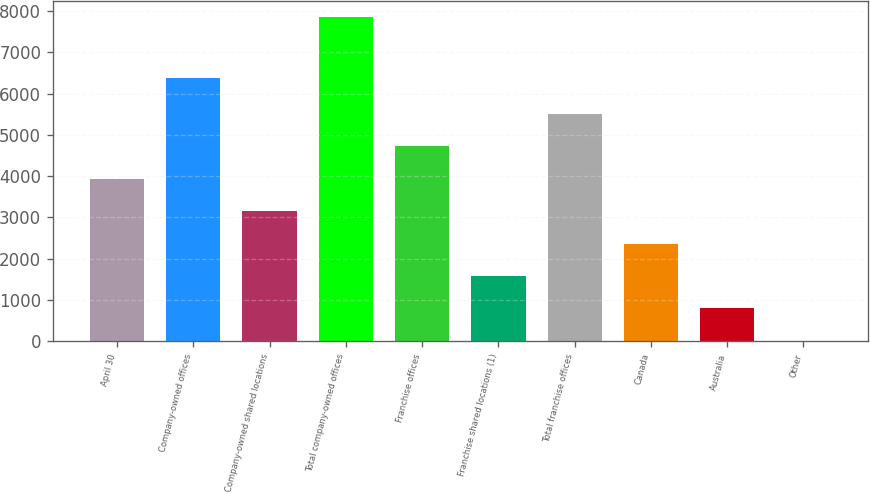Convert chart. <chart><loc_0><loc_0><loc_500><loc_500><bar_chart><fcel>April 30<fcel>Company-owned offices<fcel>Company-owned shared locations<fcel>Total company-owned offices<fcel>Franchise offices<fcel>Franchise shared locations (1)<fcel>Total franchise offices<fcel>Canada<fcel>Australia<fcel>Other<nl><fcel>3935<fcel>6387<fcel>3150<fcel>7860<fcel>4720<fcel>1580<fcel>5505<fcel>2365<fcel>795<fcel>10<nl></chart> 